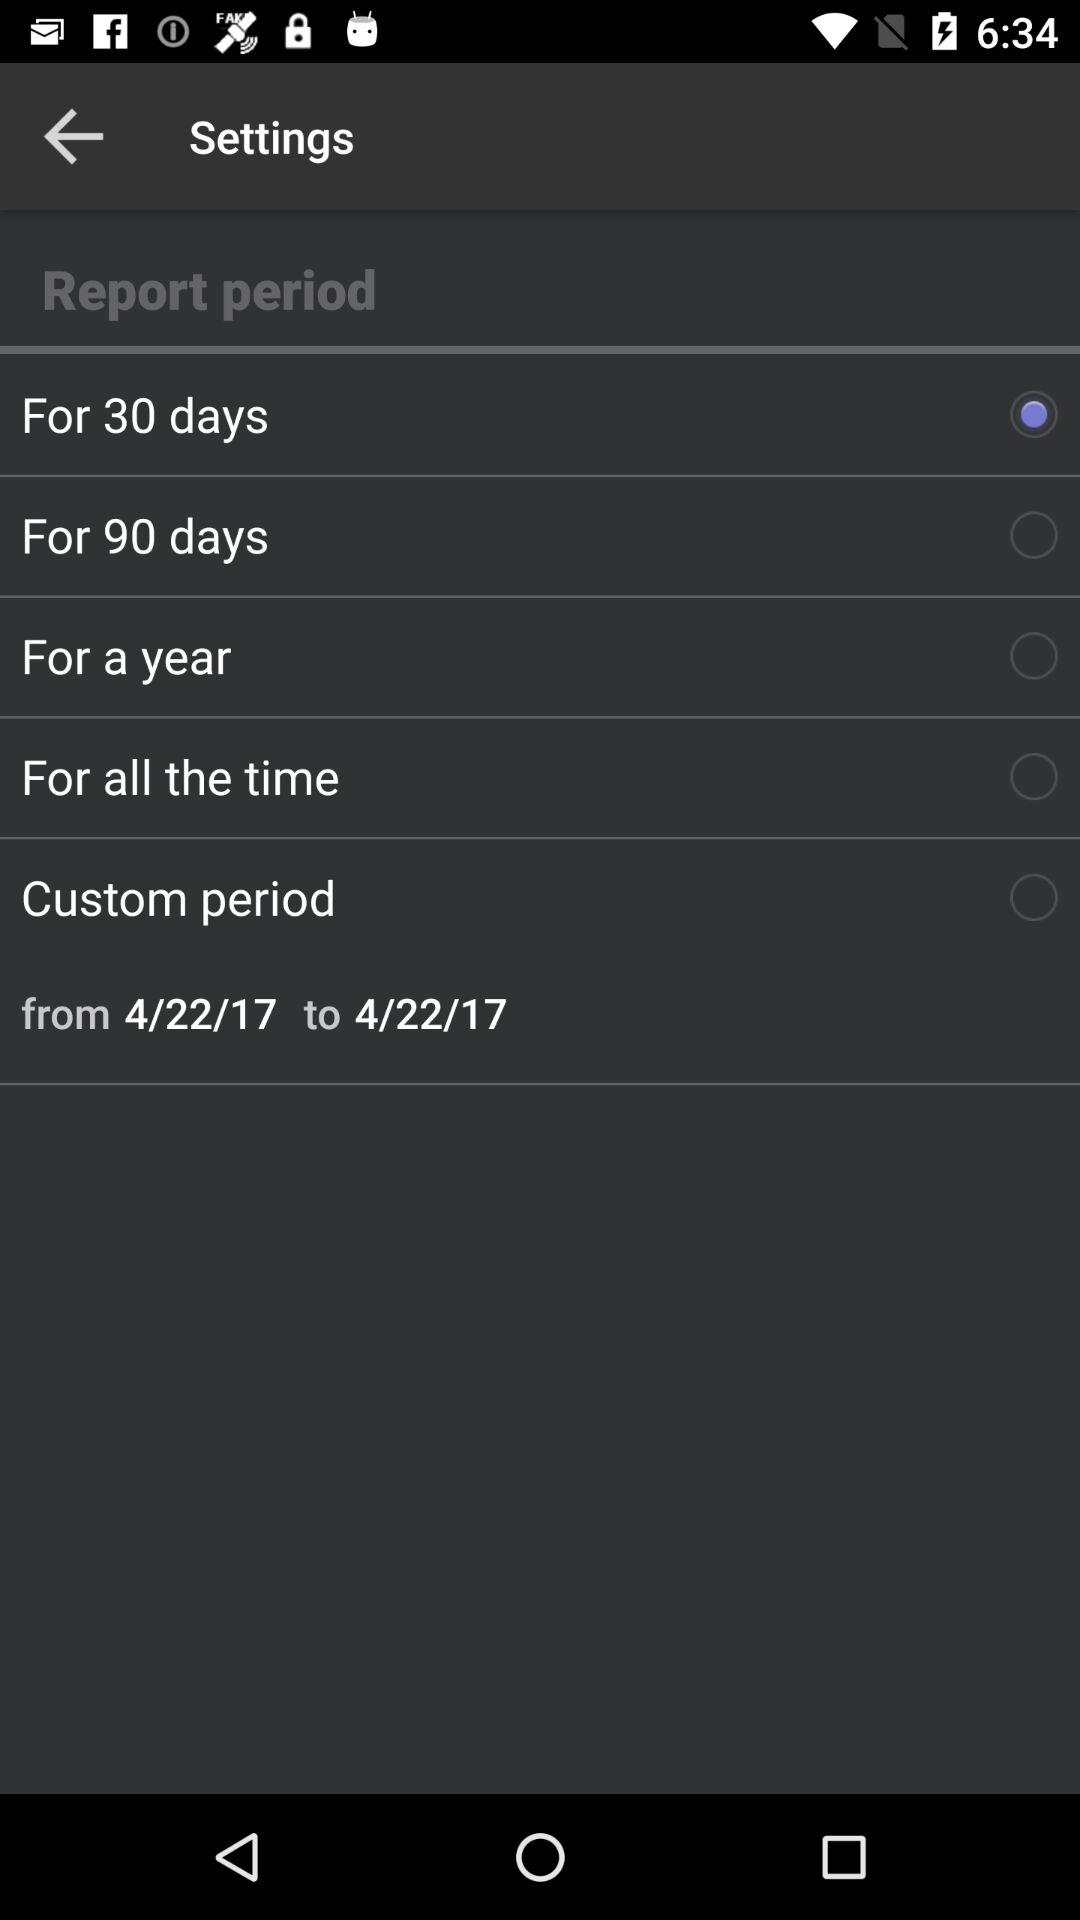Which option is selected for "Report period"? The selected option is "For 30 days". 